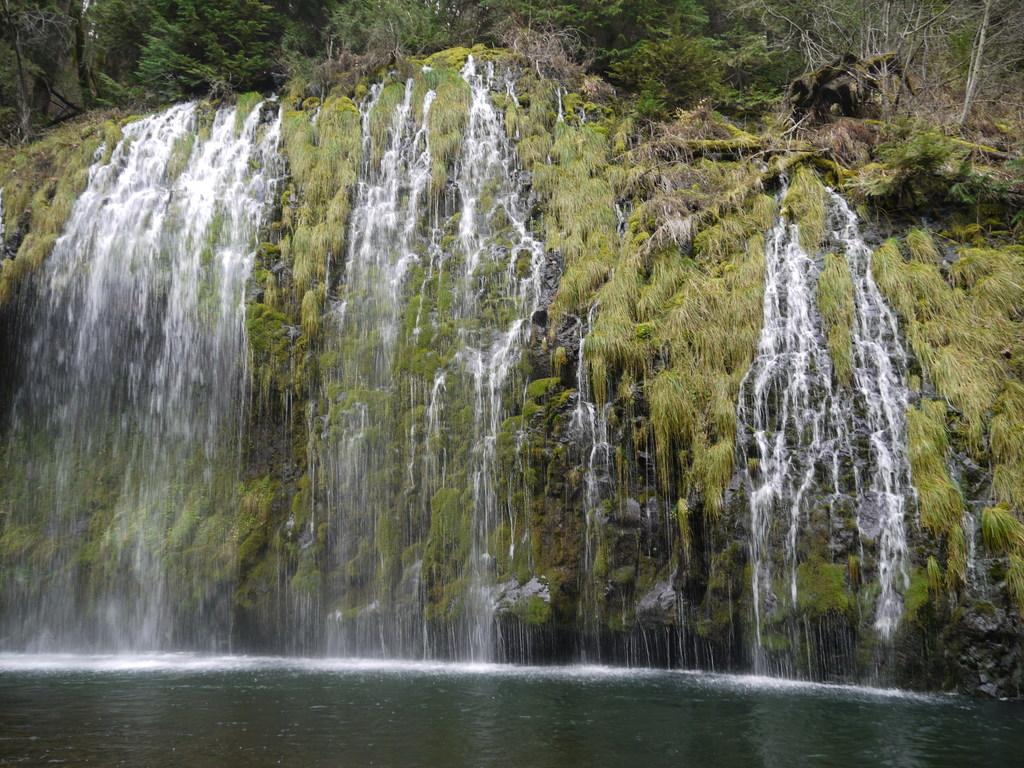What is visible in the image? Water is visible in the image. What can be seen in the background of the image? There are trees in the background of the image. What type of committee is meeting in the image? There is no committee present in the image; it features water and trees. How many circles can be seen in the image? There are no circles present in the image. 